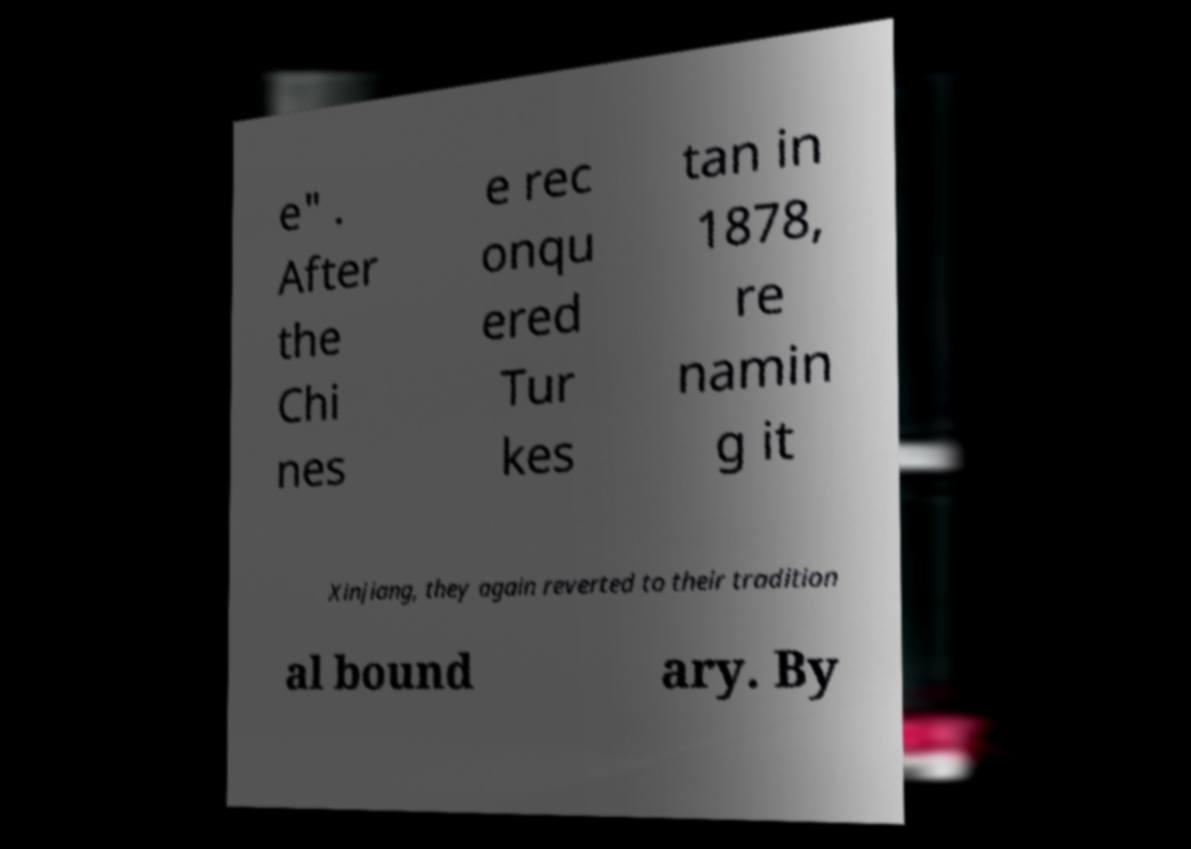I need the written content from this picture converted into text. Can you do that? e" . After the Chi nes e rec onqu ered Tur kes tan in 1878, re namin g it Xinjiang, they again reverted to their tradition al bound ary. By 